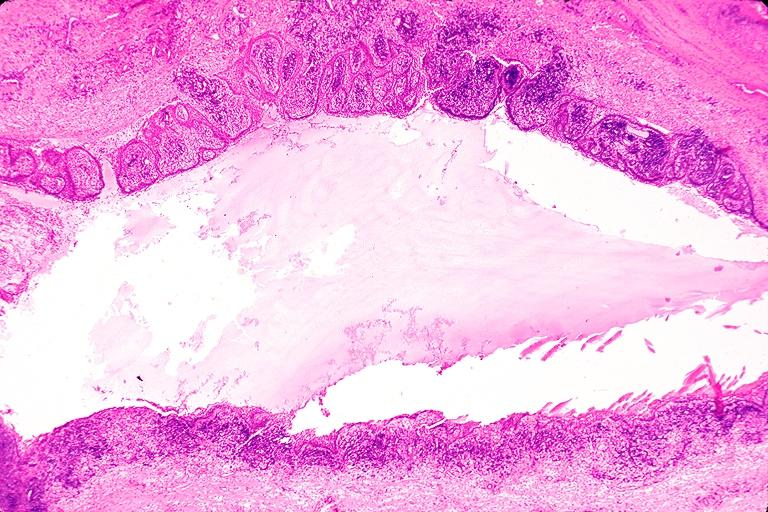what is present?
Answer the question using a single word or phrase. Oral 